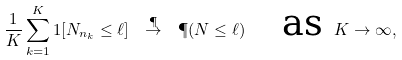<formula> <loc_0><loc_0><loc_500><loc_500>\frac { 1 } { K } \sum _ { k = 1 } ^ { K } 1 [ N _ { n _ { k } } \leq \ell ] \ \stackrel { \P } { \to } \ \P ( N \leq \ell ) \quad \text {as } K \to \infty ,</formula> 